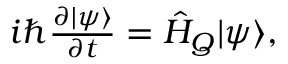Convert formula to latex. <formula><loc_0><loc_0><loc_500><loc_500>\begin{array} { r } { i \hbar { } \partial | \psi \rangle } { \partial t } = { \hat { H } } _ { Q } | \psi \rangle , } \end{array}</formula> 